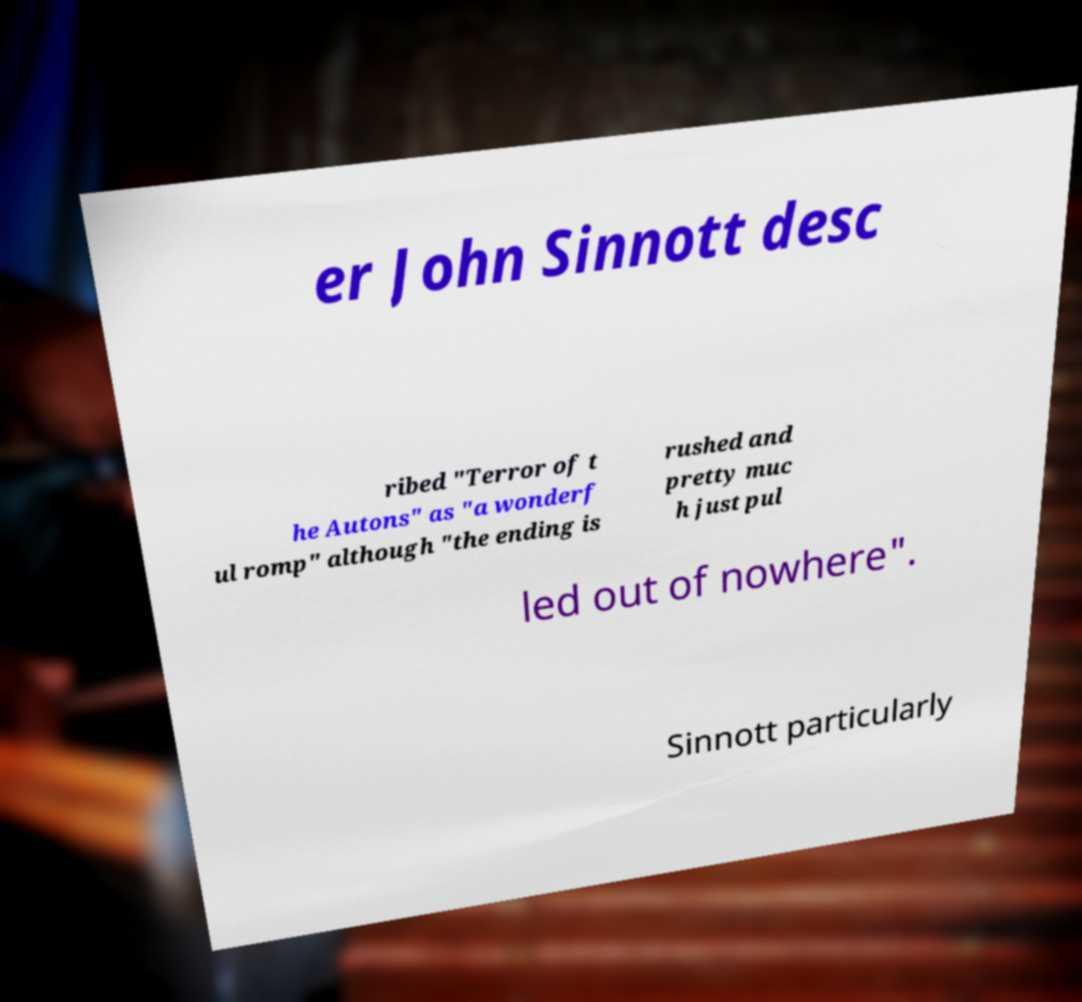Please read and relay the text visible in this image. What does it say? er John Sinnott desc ribed "Terror of t he Autons" as "a wonderf ul romp" although "the ending is rushed and pretty muc h just pul led out of nowhere". Sinnott particularly 